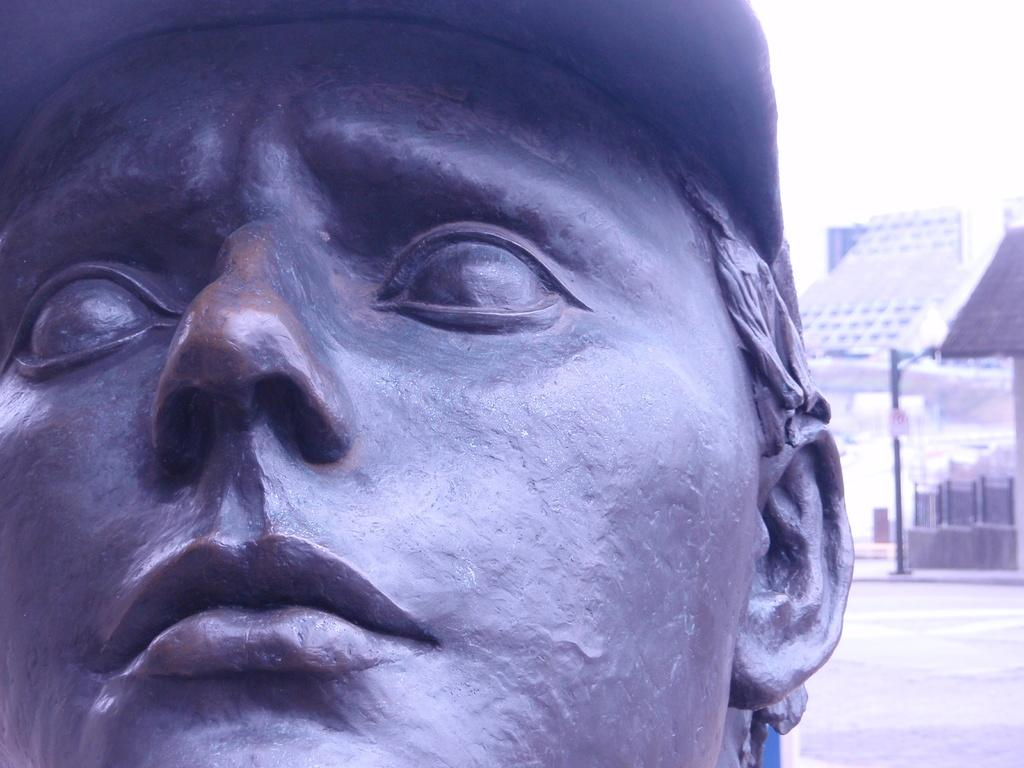What is the main subject of the image? There is a statue of a person's face in the image. What color is the statue? The statue is black in color. What can be seen in the background of the image? There are buildings in the background of the image. What other object is visible in the image? There appears to be a pole in the image. Is there a team of people playing on the swing in the image? There is no swing or team of people present in the image. 